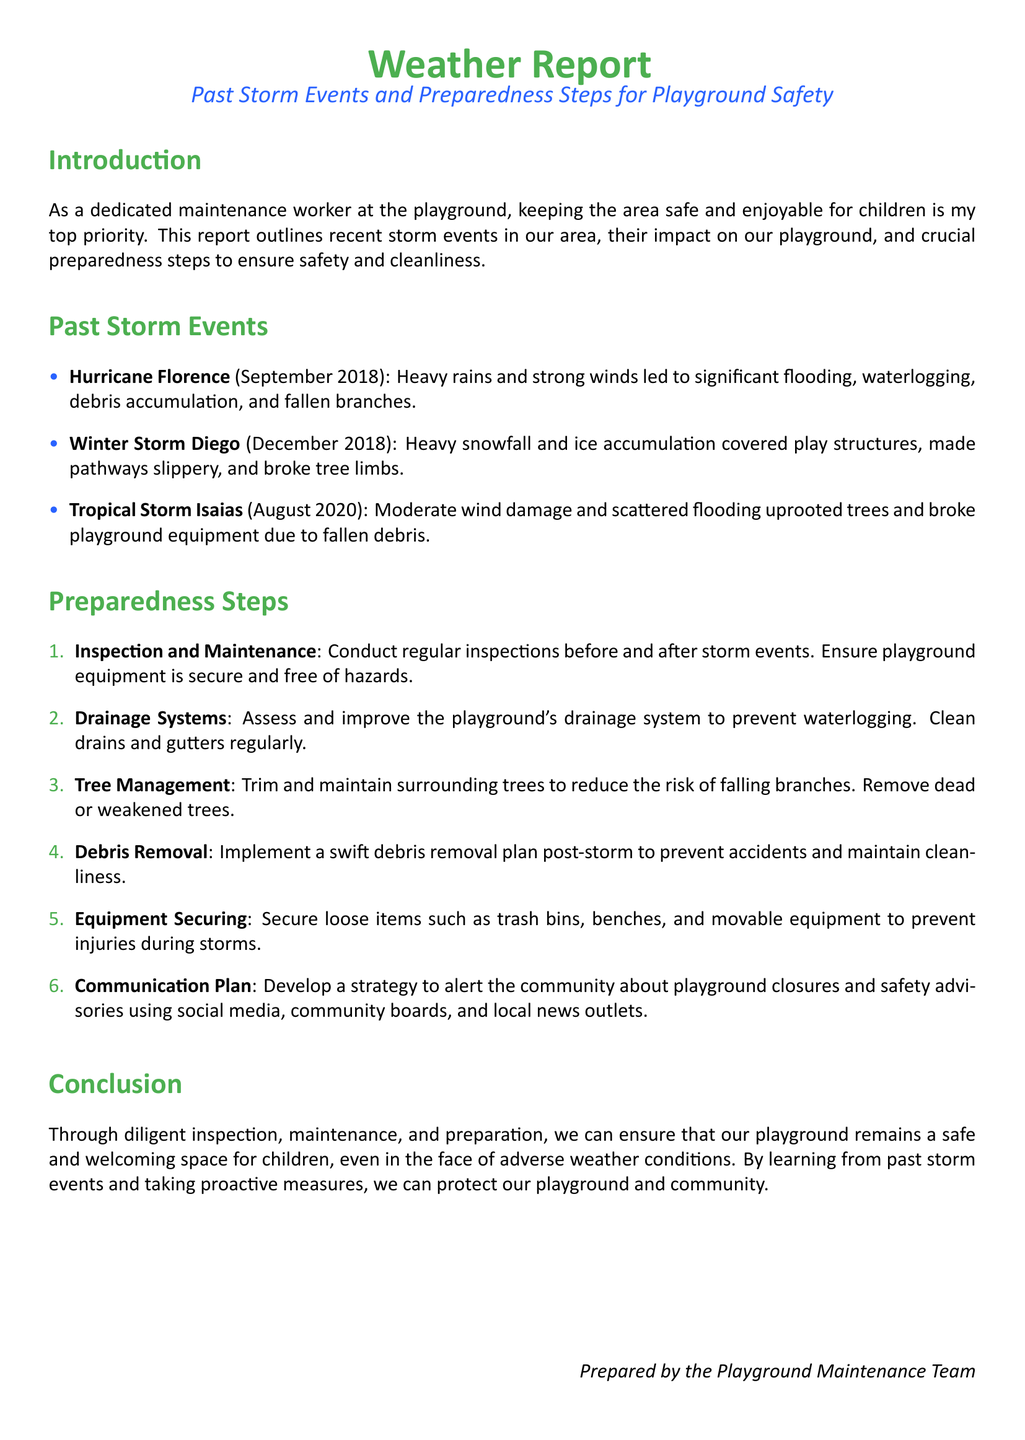What was the name of the storm in September 2018? The document mentions Hurricane Florence as the storm that occurred in September 2018.
Answer: Hurricane Florence What type of storm was Winter Storm Diego? The document states that Winter Storm Diego involved heavy snowfall and ice accumulation.
Answer: Winter Storm How many past storm events are listed in the document? The document lists three past storm events, which are Hurricane Florence, Winter Storm Diego, and Tropical Storm Isaias.
Answer: Three What is the first preparedness step mentioned? The document presents Inspection and Maintenance as the first preparedness step to ensure playground safety.
Answer: Inspection and Maintenance What caused damage during Tropical Storm Isaias? The document indicates that moderate wind damage and scattered flooding caused issues during Tropical Storm Isaias.
Answer: Moderate wind damage and scattered flooding What should be regularly cleaned to improve drainage? The document highlights that drains and gutters should be cleaned regularly to maintain the playground’s drainage system.
Answer: Drains and gutters Which community communication method is suggested in the report? The document suggests using social media, community boards, and local news outlets to alert the community about playground closures.
Answer: Social media What can be done post-storm to prevent accidents? The report emphasizes the importance of implementing a swift debris removal plan after a storm to ensure safety.
Answer: Debris removal plan 